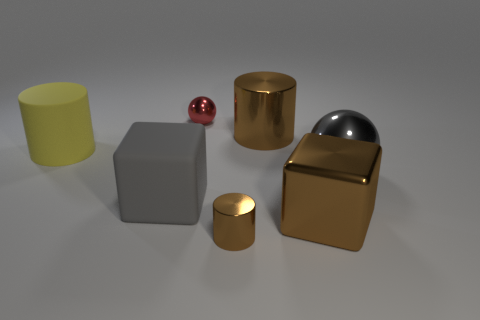There is a thing that is both on the left side of the big gray metal object and on the right side of the large metal cylinder; what size is it?
Keep it short and to the point. Large. How many metallic objects are large cylinders or brown cylinders?
Make the answer very short. 2. There is a large metallic cylinder; does it have the same color as the tiny thing in front of the big gray block?
Your answer should be compact. Yes. The small brown thing has what shape?
Offer a terse response. Cylinder. There is a sphere left of the tiny object that is in front of the small shiny thing left of the tiny brown thing; how big is it?
Your answer should be very brief. Small. What number of other objects are the same shape as the big yellow thing?
Give a very brief answer. 2. There is a large brown thing in front of the big gray shiny sphere; does it have the same shape as the gray matte object in front of the big brown metallic cylinder?
Keep it short and to the point. Yes. What number of cylinders are big gray metallic things or gray objects?
Ensure brevity in your answer.  0. There is a small object behind the big brown thing behind the thing that is on the right side of the big brown block; what is it made of?
Give a very brief answer. Metal. How many other things are the same size as the red thing?
Your response must be concise. 1. 